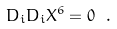Convert formula to latex. <formula><loc_0><loc_0><loc_500><loc_500>D _ { i } D _ { i } X ^ { 6 } = 0 \ .</formula> 